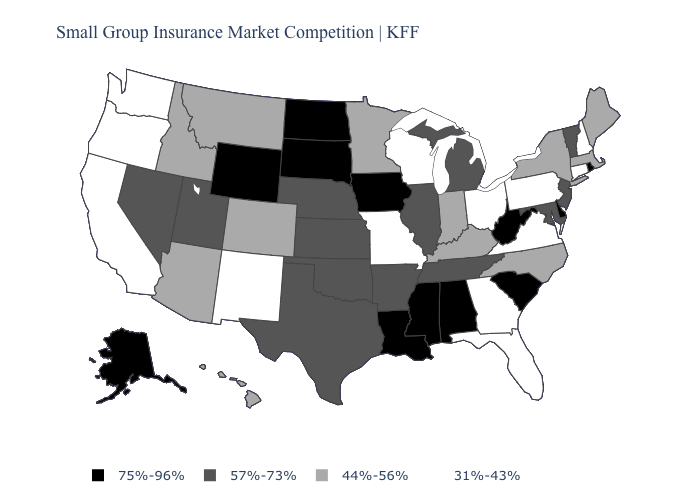Name the states that have a value in the range 57%-73%?
Be succinct. Arkansas, Illinois, Kansas, Maryland, Michigan, Nebraska, Nevada, New Jersey, Oklahoma, Tennessee, Texas, Utah, Vermont. Does the map have missing data?
Give a very brief answer. No. Name the states that have a value in the range 44%-56%?
Give a very brief answer. Arizona, Colorado, Hawaii, Idaho, Indiana, Kentucky, Maine, Massachusetts, Minnesota, Montana, New York, North Carolina. Among the states that border New Hampshire , does Massachusetts have the lowest value?
Short answer required. Yes. Does Connecticut have the lowest value in the USA?
Quick response, please. Yes. Name the states that have a value in the range 75%-96%?
Short answer required. Alabama, Alaska, Delaware, Iowa, Louisiana, Mississippi, North Dakota, Rhode Island, South Carolina, South Dakota, West Virginia, Wyoming. Name the states that have a value in the range 44%-56%?
Concise answer only. Arizona, Colorado, Hawaii, Idaho, Indiana, Kentucky, Maine, Massachusetts, Minnesota, Montana, New York, North Carolina. What is the value of Pennsylvania?
Short answer required. 31%-43%. Is the legend a continuous bar?
Keep it brief. No. What is the lowest value in states that border Rhode Island?
Give a very brief answer. 31%-43%. What is the value of Florida?
Concise answer only. 31%-43%. Name the states that have a value in the range 31%-43%?
Quick response, please. California, Connecticut, Florida, Georgia, Missouri, New Hampshire, New Mexico, Ohio, Oregon, Pennsylvania, Virginia, Washington, Wisconsin. Which states have the lowest value in the USA?
Short answer required. California, Connecticut, Florida, Georgia, Missouri, New Hampshire, New Mexico, Ohio, Oregon, Pennsylvania, Virginia, Washington, Wisconsin. Does the first symbol in the legend represent the smallest category?
Be succinct. No. What is the value of Florida?
Keep it brief. 31%-43%. 